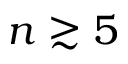<formula> <loc_0><loc_0><loc_500><loc_500>n \gtrsim 5</formula> 